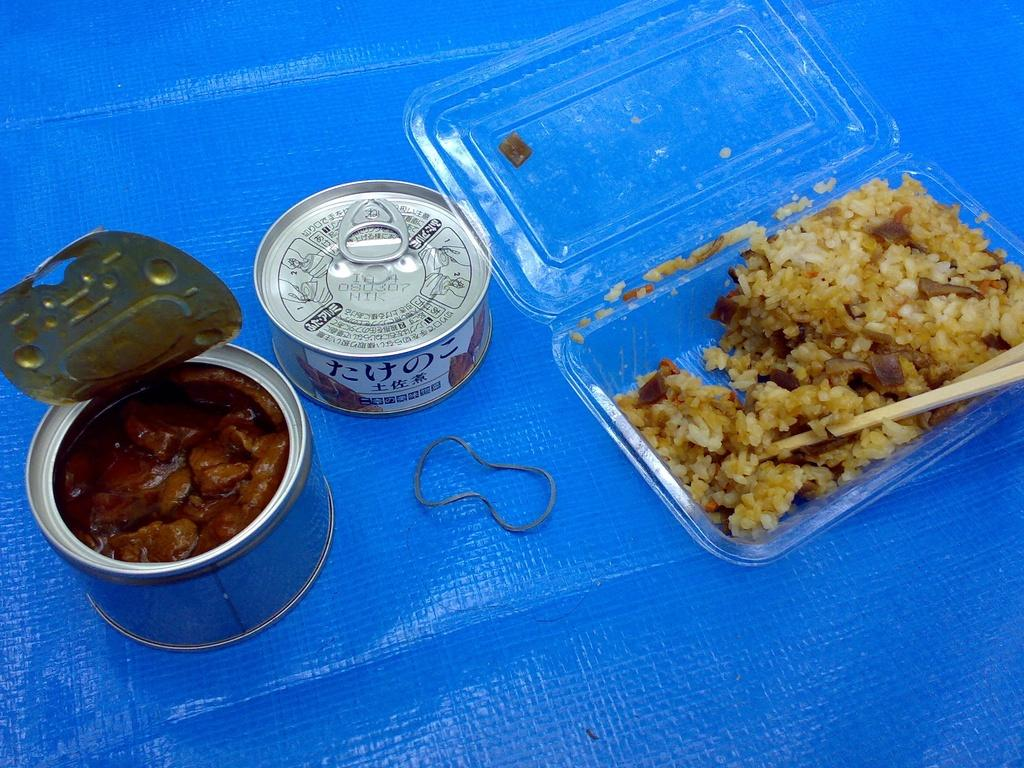What type of food containers are visible in the image? There are food cans in the image. What other type of food container can be seen in the image? There is a food item in a plastic box in the image. What else is present in the image besides food containers? There are other objects in the image. What is the color of the surface on which the objects are placed? The objects are on a blue color surface. How many bananas can be seen growing in the field in the image? There are no bananas or fields present in the image. 